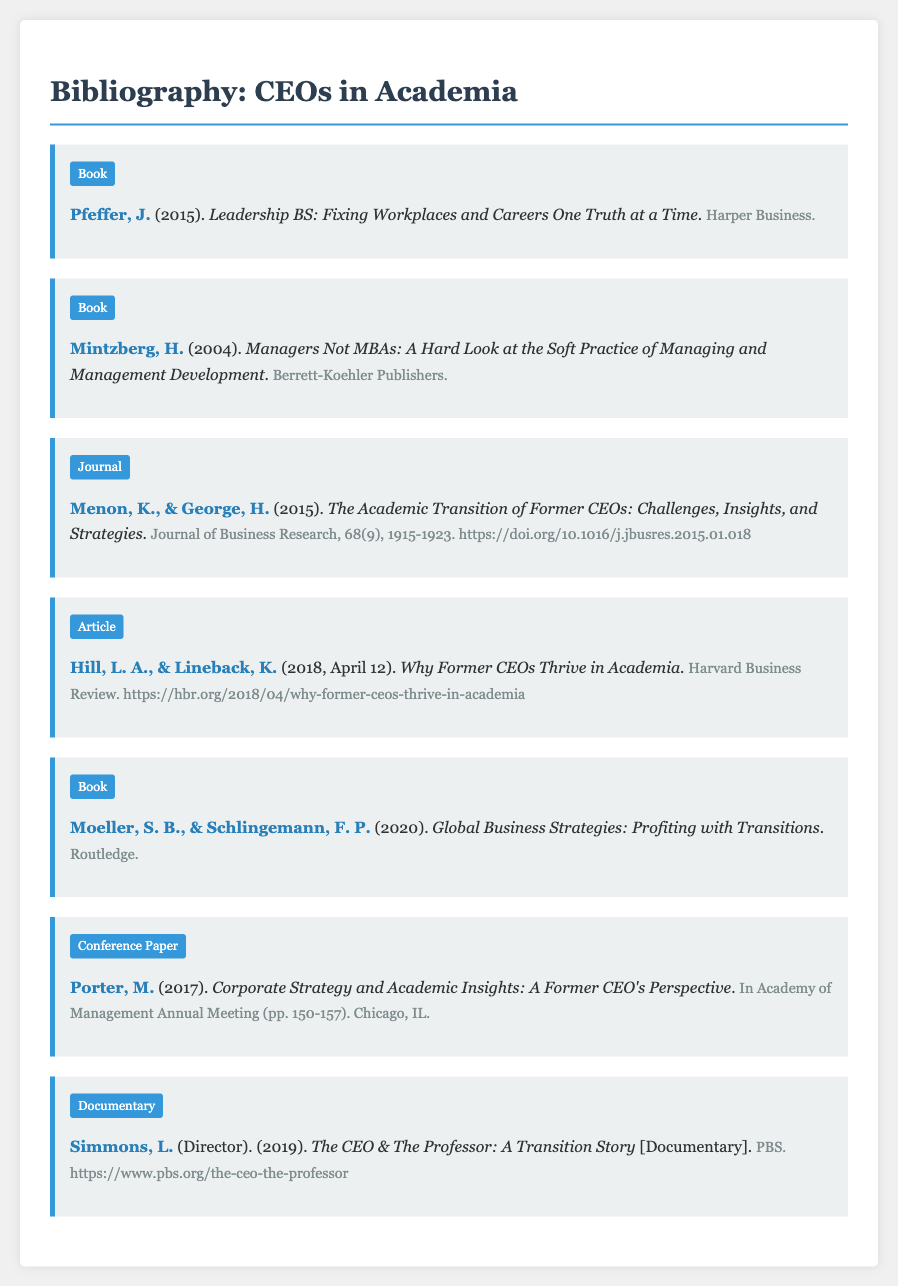what is the title of Pfeffer's book? The title of Pfeffer's book is explicitly mentioned as "Leadership BS: Fixing Workplaces and Careers One Truth at a Time."
Answer: Leadership BS: Fixing Workplaces and Careers One Truth at a Time who are the authors of the article "Why Former CEOs Thrive in Academia"? The authors of the article are noted directly in the document as "Hill, L. A., & Lineback, K."
Answer: Hill, L. A., & Lineback, K what year was the documentary directed by Simmons released? The year of release for the documentary is stated within the details as "2019."
Answer: 2019 how many pages does Porter's conference paper cover? The pagination of Porter's conference paper (pp. 150-157) indicates the range of pages covered.
Answer: 8 pages which publisher released the book by Mintzberg? The book by Mintzberg includes the publisher mentioned in the details, "Berrett-Koehler Publishers."
Answer: Berrett-Koehler Publishers what is the focus of Menon & George's journal article? The focus is indicated in the title as "The Academic Transition of Former CEOs: Challenges, Insights, and Strategies."
Answer: Academic Transition of Former CEOs who directed the documentary titled "The CEO & The Professor: A Transition Story"? The director's name is provided in parentheses as "Simmons, L."
Answer: Simmons, L what is the main theme of Moeller and Schlingemann's book? The title suggests a focus on business strategies with transitions, articulated in "Global Business Strategies: Profiting with Transitions."
Answer: Global Business Strategies: Profiting with Transitions 